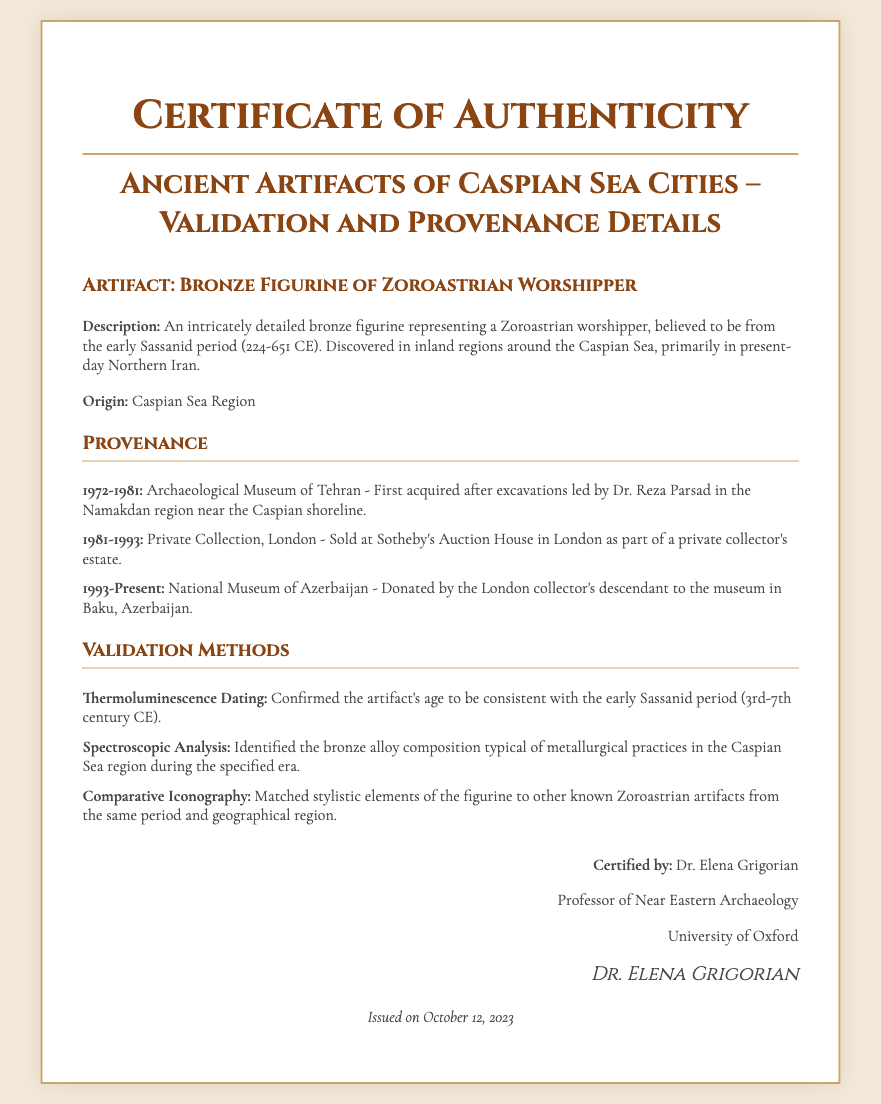What is the artifact described? The document specifies the artifact as a "Bronze Figurine of Zoroastrian Worshipper."
Answer: Bronze Figurine of Zoroastrian Worshipper Who certified the artifact? The certification is issued by Dr. Elena Grigorian, whose name appears at the end of the document.
Answer: Dr. Elena Grigorian What period does the artifact belong to? The document notes the artifact's association with the early Sassanid period, providing time context.
Answer: early Sassanid period (224-651 CE) Where was the artifact discovered? It is stated in the document that the artifact was discovered in inland regions around the Caspian Sea.
Answer: inland regions around the Caspian Sea What validation method confirmed the age of the artifact? The document mentions "Thermoluminescence Dating" as the method used for age confirmation.
Answer: Thermoluminescence Dating When was the artifact donated to the National Museum of Azerbaijan? The document indicates the donation was made in the present timeframe after 1993.
Answer: 1993-Present What city is the National Museum of Azerbaijan located in? The document specifies that the museum is located in Baku, Azerbaijan.
Answer: Baku, Azerbaijan What is the hierarchy of ownership from 1972 to present? The provenance states it transitioned from the Archaeological Museum of Tehran to a private collection and then to the National Museum of Azerbaijan.
Answer: Archaeological Museum of Tehran - Private Collection, London - National Museum of Azerbaijan What kind of analysis was used to identify the bronze alloy? The document points to "Spectroscopic Analysis" as the method used to identify the bronze alloy composition.
Answer: Spectroscopic Analysis 